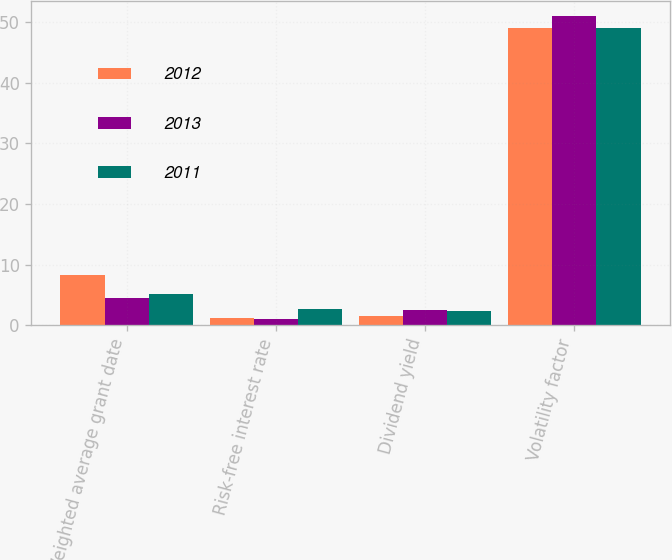Convert chart. <chart><loc_0><loc_0><loc_500><loc_500><stacked_bar_chart><ecel><fcel>Weighted average grant date<fcel>Risk-free interest rate<fcel>Dividend yield<fcel>Volatility factor<nl><fcel>2012<fcel>8.35<fcel>1.22<fcel>1.47<fcel>49.07<nl><fcel>2013<fcel>4.44<fcel>1.09<fcel>2.57<fcel>50.97<nl><fcel>2011<fcel>5.07<fcel>2.69<fcel>2.35<fcel>49.03<nl></chart> 